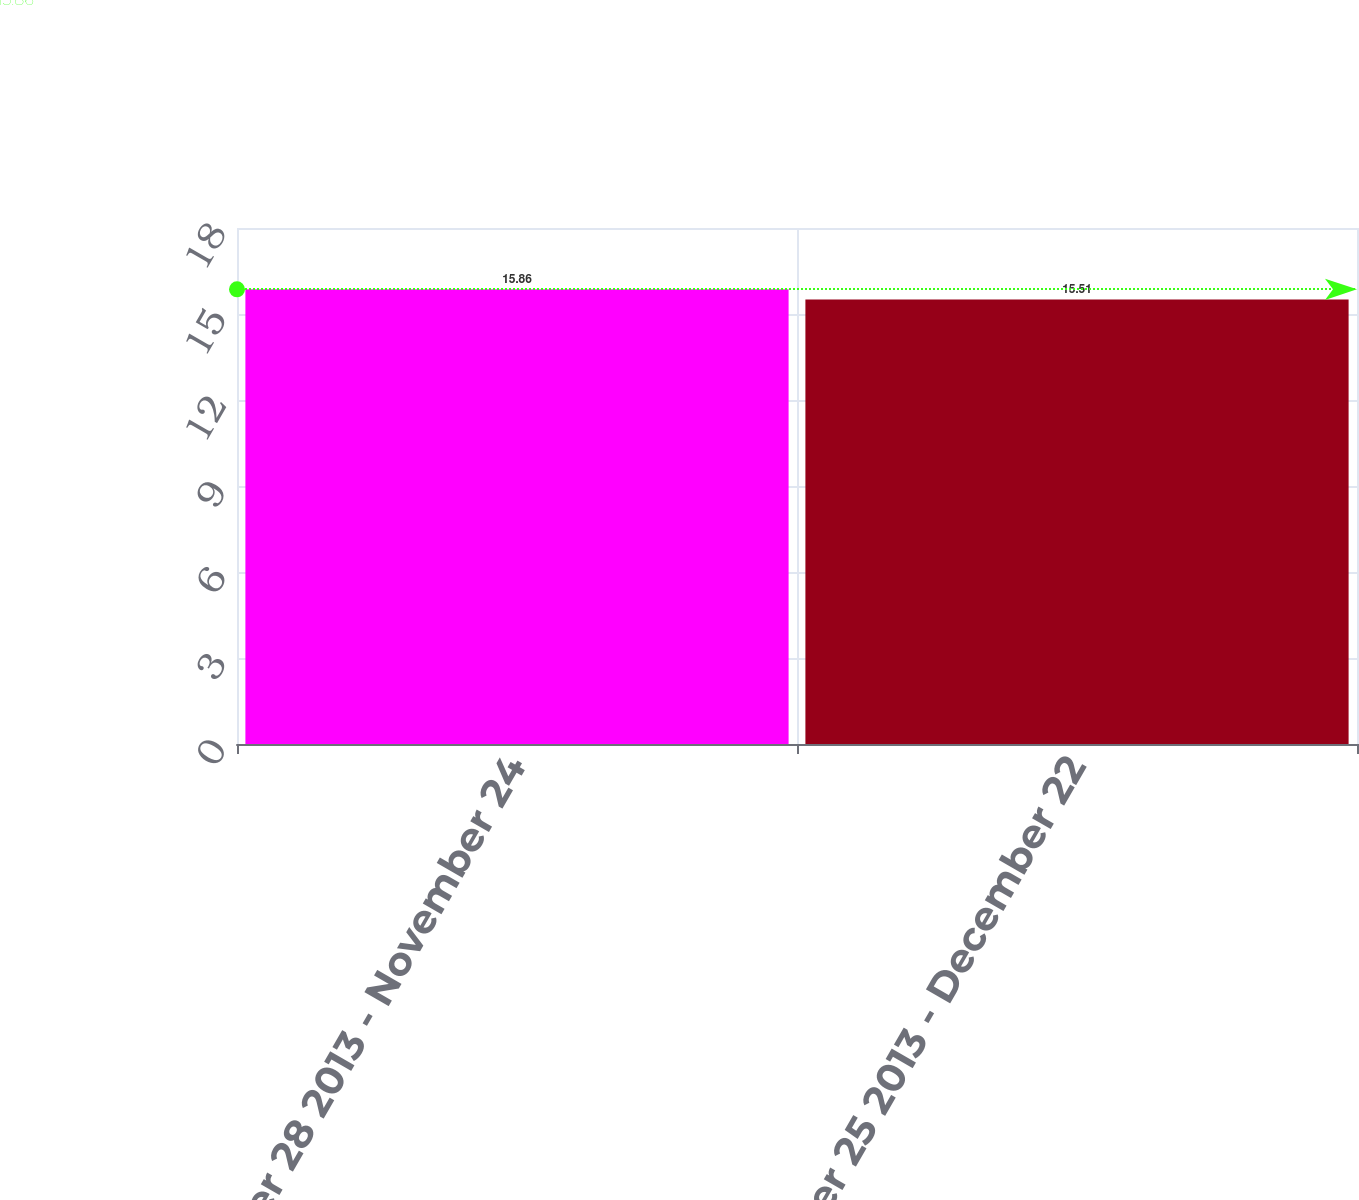<chart> <loc_0><loc_0><loc_500><loc_500><bar_chart><fcel>October 28 2013 - November 24<fcel>November 25 2013 - December 22<nl><fcel>15.86<fcel>15.51<nl></chart> 